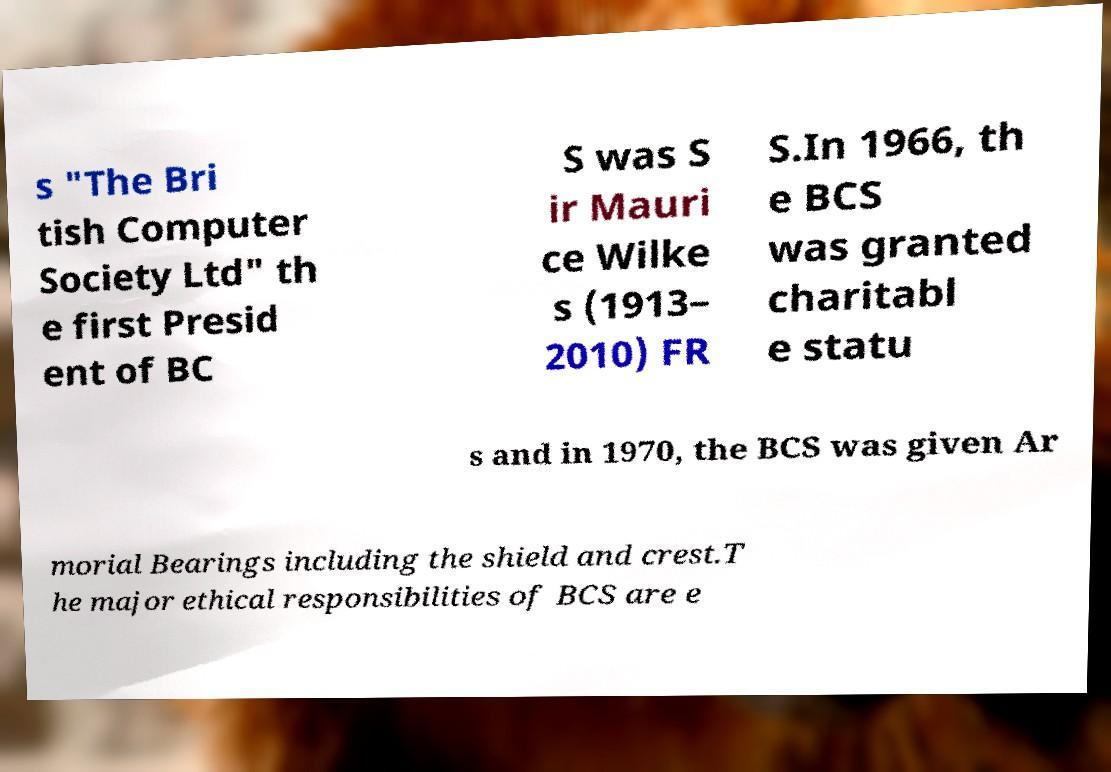Please read and relay the text visible in this image. What does it say? s "The Bri tish Computer Society Ltd" th e first Presid ent of BC S was S ir Mauri ce Wilke s (1913– 2010) FR S.In 1966, th e BCS was granted charitabl e statu s and in 1970, the BCS was given Ar morial Bearings including the shield and crest.T he major ethical responsibilities of BCS are e 